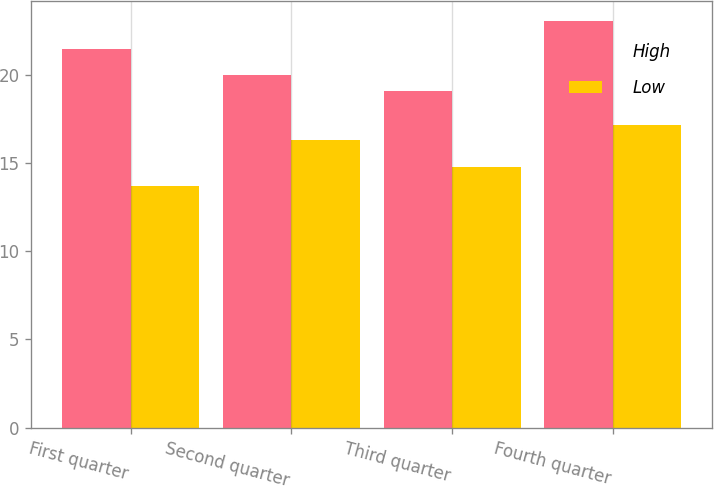Convert chart. <chart><loc_0><loc_0><loc_500><loc_500><stacked_bar_chart><ecel><fcel>First quarter<fcel>Second quarter<fcel>Third quarter<fcel>Fourth quarter<nl><fcel>High<fcel>21.45<fcel>19.98<fcel>19.09<fcel>23.03<nl><fcel>Low<fcel>13.67<fcel>16.32<fcel>14.79<fcel>17.17<nl></chart> 